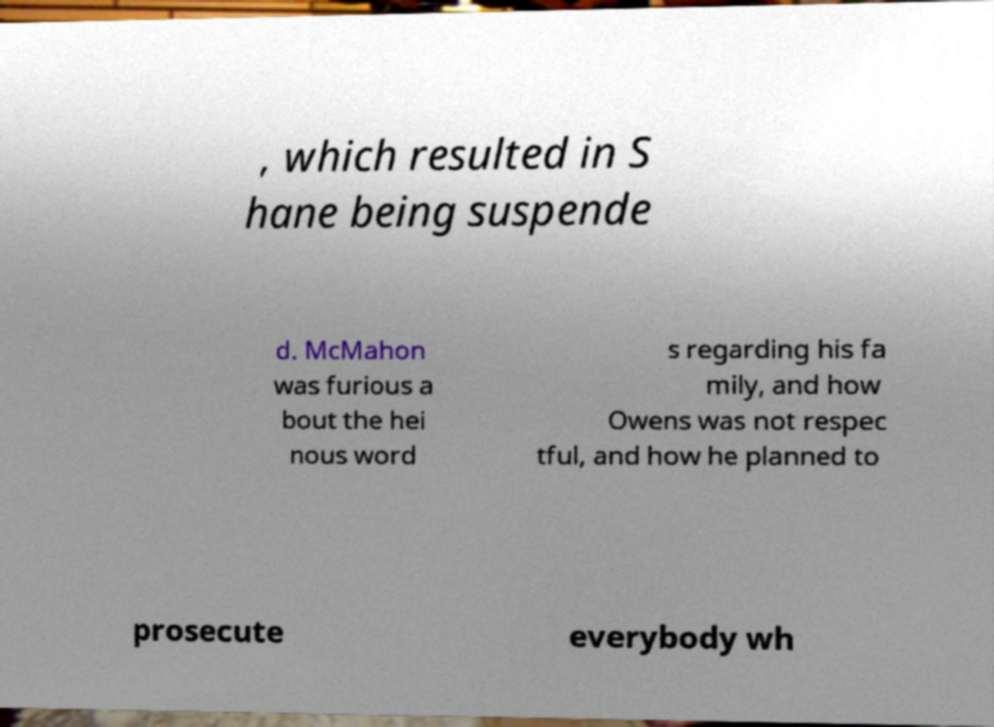Can you accurately transcribe the text from the provided image for me? , which resulted in S hane being suspende d. McMahon was furious a bout the hei nous word s regarding his fa mily, and how Owens was not respec tful, and how he planned to prosecute everybody wh 